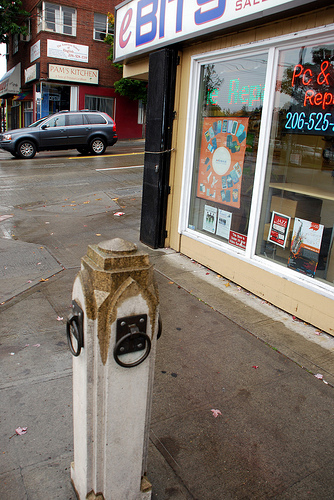<image>
Is the sign board on the wall? Yes. Looking at the image, I can see the sign board is positioned on top of the wall, with the wall providing support. 